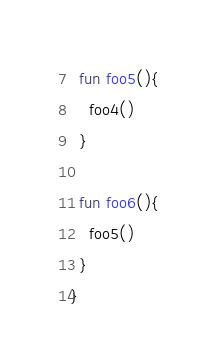Convert code to text. <code><loc_0><loc_0><loc_500><loc_500><_Kotlin_>
  fun foo5(){
    foo4()
  }

  fun foo6(){
    foo5()
  }
}</code> 